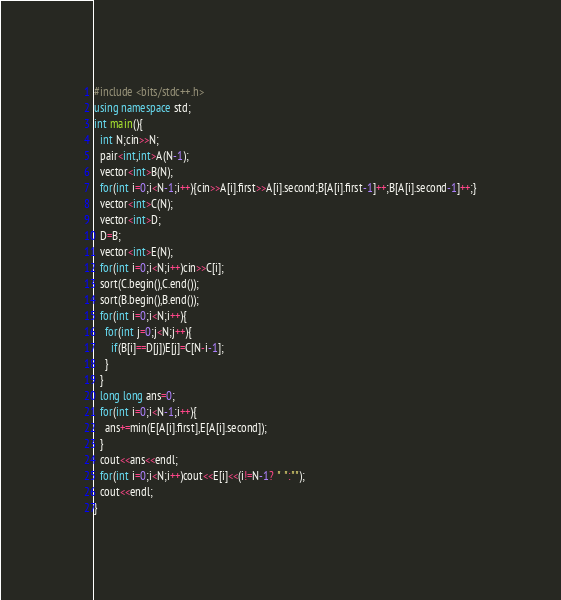<code> <loc_0><loc_0><loc_500><loc_500><_C++_>#include <bits/stdc++.h>
using namespace std;
int main(){
  int N;cin>>N;
  pair<int,int>A(N-1);
  vector<int>B(N);
  for(int i=0;i<N-1;i++){cin>>A[i].first>>A[i].second;B[A[i].first-1]++;B[A[i].second-1]++;}
  vector<int>C(N);
  vector<int>D;
  D=B;
  vector<int>E(N);
  for(int i=0;i<N;i++)cin>>C[i];
  sort(C.begin(),C.end());
  sort(B.begin(),B.end());
  for(int i=0;i<N;i++){
    for(int j=0;j<N;j++){
      if(B[i]==D[j])E[j]=C[N-i-1];
    }
  }
  long long ans=0;
  for(int i=0;i<N-1;i++){
    ans+=min(E[A[i].first],E[A[i].second]);
  }
  cout<<ans<<endl;
  for(int i=0;i<N;i++)cout<<E[i]<<(i!=N-1? " ":"");
  cout<<endl;
}</code> 